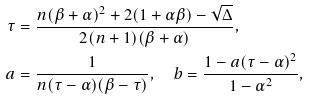Convert formula to latex. <formula><loc_0><loc_0><loc_500><loc_500>\tau & = \frac { n ( \beta + \alpha ) ^ { 2 } + 2 ( 1 + \alpha \beta ) - \sqrt { \Delta } } { 2 ( n + 1 ) ( \beta + \alpha ) } , \\ a & = \frac { 1 } { n ( \tau - \alpha ) ( \beta - \tau ) } , \quad b = \frac { 1 - a ( \tau - \alpha ) ^ { 2 } } { 1 - \alpha ^ { 2 } } ,</formula> 